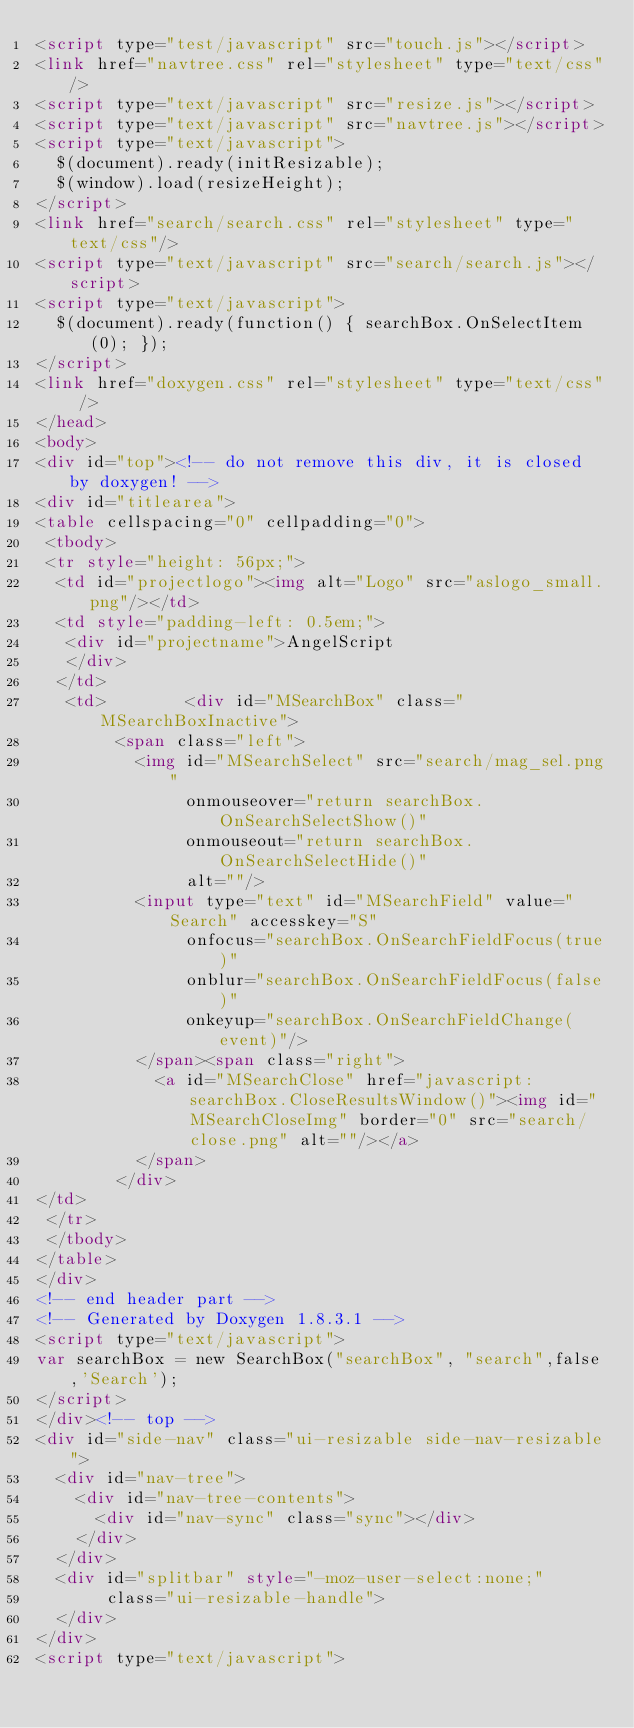Convert code to text. <code><loc_0><loc_0><loc_500><loc_500><_HTML_><script type="test/javascript" src="touch.js"></script>
<link href="navtree.css" rel="stylesheet" type="text/css"/>
<script type="text/javascript" src="resize.js"></script>
<script type="text/javascript" src="navtree.js"></script>
<script type="text/javascript">
  $(document).ready(initResizable);
  $(window).load(resizeHeight);
</script>
<link href="search/search.css" rel="stylesheet" type="text/css"/>
<script type="text/javascript" src="search/search.js"></script>
<script type="text/javascript">
  $(document).ready(function() { searchBox.OnSelectItem(0); });
</script>
<link href="doxygen.css" rel="stylesheet" type="text/css" />
</head>
<body>
<div id="top"><!-- do not remove this div, it is closed by doxygen! -->
<div id="titlearea">
<table cellspacing="0" cellpadding="0">
 <tbody>
 <tr style="height: 56px;">
  <td id="projectlogo"><img alt="Logo" src="aslogo_small.png"/></td>
  <td style="padding-left: 0.5em;">
   <div id="projectname">AngelScript
   </div>
  </td>
   <td>        <div id="MSearchBox" class="MSearchBoxInactive">
        <span class="left">
          <img id="MSearchSelect" src="search/mag_sel.png"
               onmouseover="return searchBox.OnSearchSelectShow()"
               onmouseout="return searchBox.OnSearchSelectHide()"
               alt=""/>
          <input type="text" id="MSearchField" value="Search" accesskey="S"
               onfocus="searchBox.OnSearchFieldFocus(true)" 
               onblur="searchBox.OnSearchFieldFocus(false)" 
               onkeyup="searchBox.OnSearchFieldChange(event)"/>
          </span><span class="right">
            <a id="MSearchClose" href="javascript:searchBox.CloseResultsWindow()"><img id="MSearchCloseImg" border="0" src="search/close.png" alt=""/></a>
          </span>
        </div>
</td>
 </tr>
 </tbody>
</table>
</div>
<!-- end header part -->
<!-- Generated by Doxygen 1.8.3.1 -->
<script type="text/javascript">
var searchBox = new SearchBox("searchBox", "search",false,'Search');
</script>
</div><!-- top -->
<div id="side-nav" class="ui-resizable side-nav-resizable">
  <div id="nav-tree">
    <div id="nav-tree-contents">
      <div id="nav-sync" class="sync"></div>
    </div>
  </div>
  <div id="splitbar" style="-moz-user-select:none;" 
       class="ui-resizable-handle">
  </div>
</div>
<script type="text/javascript"></code> 